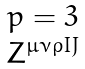Convert formula to latex. <formula><loc_0><loc_0><loc_500><loc_500>\begin{matrix} p = 3 \\ Z ^ { \mu \nu \rho I J } \end{matrix}</formula> 